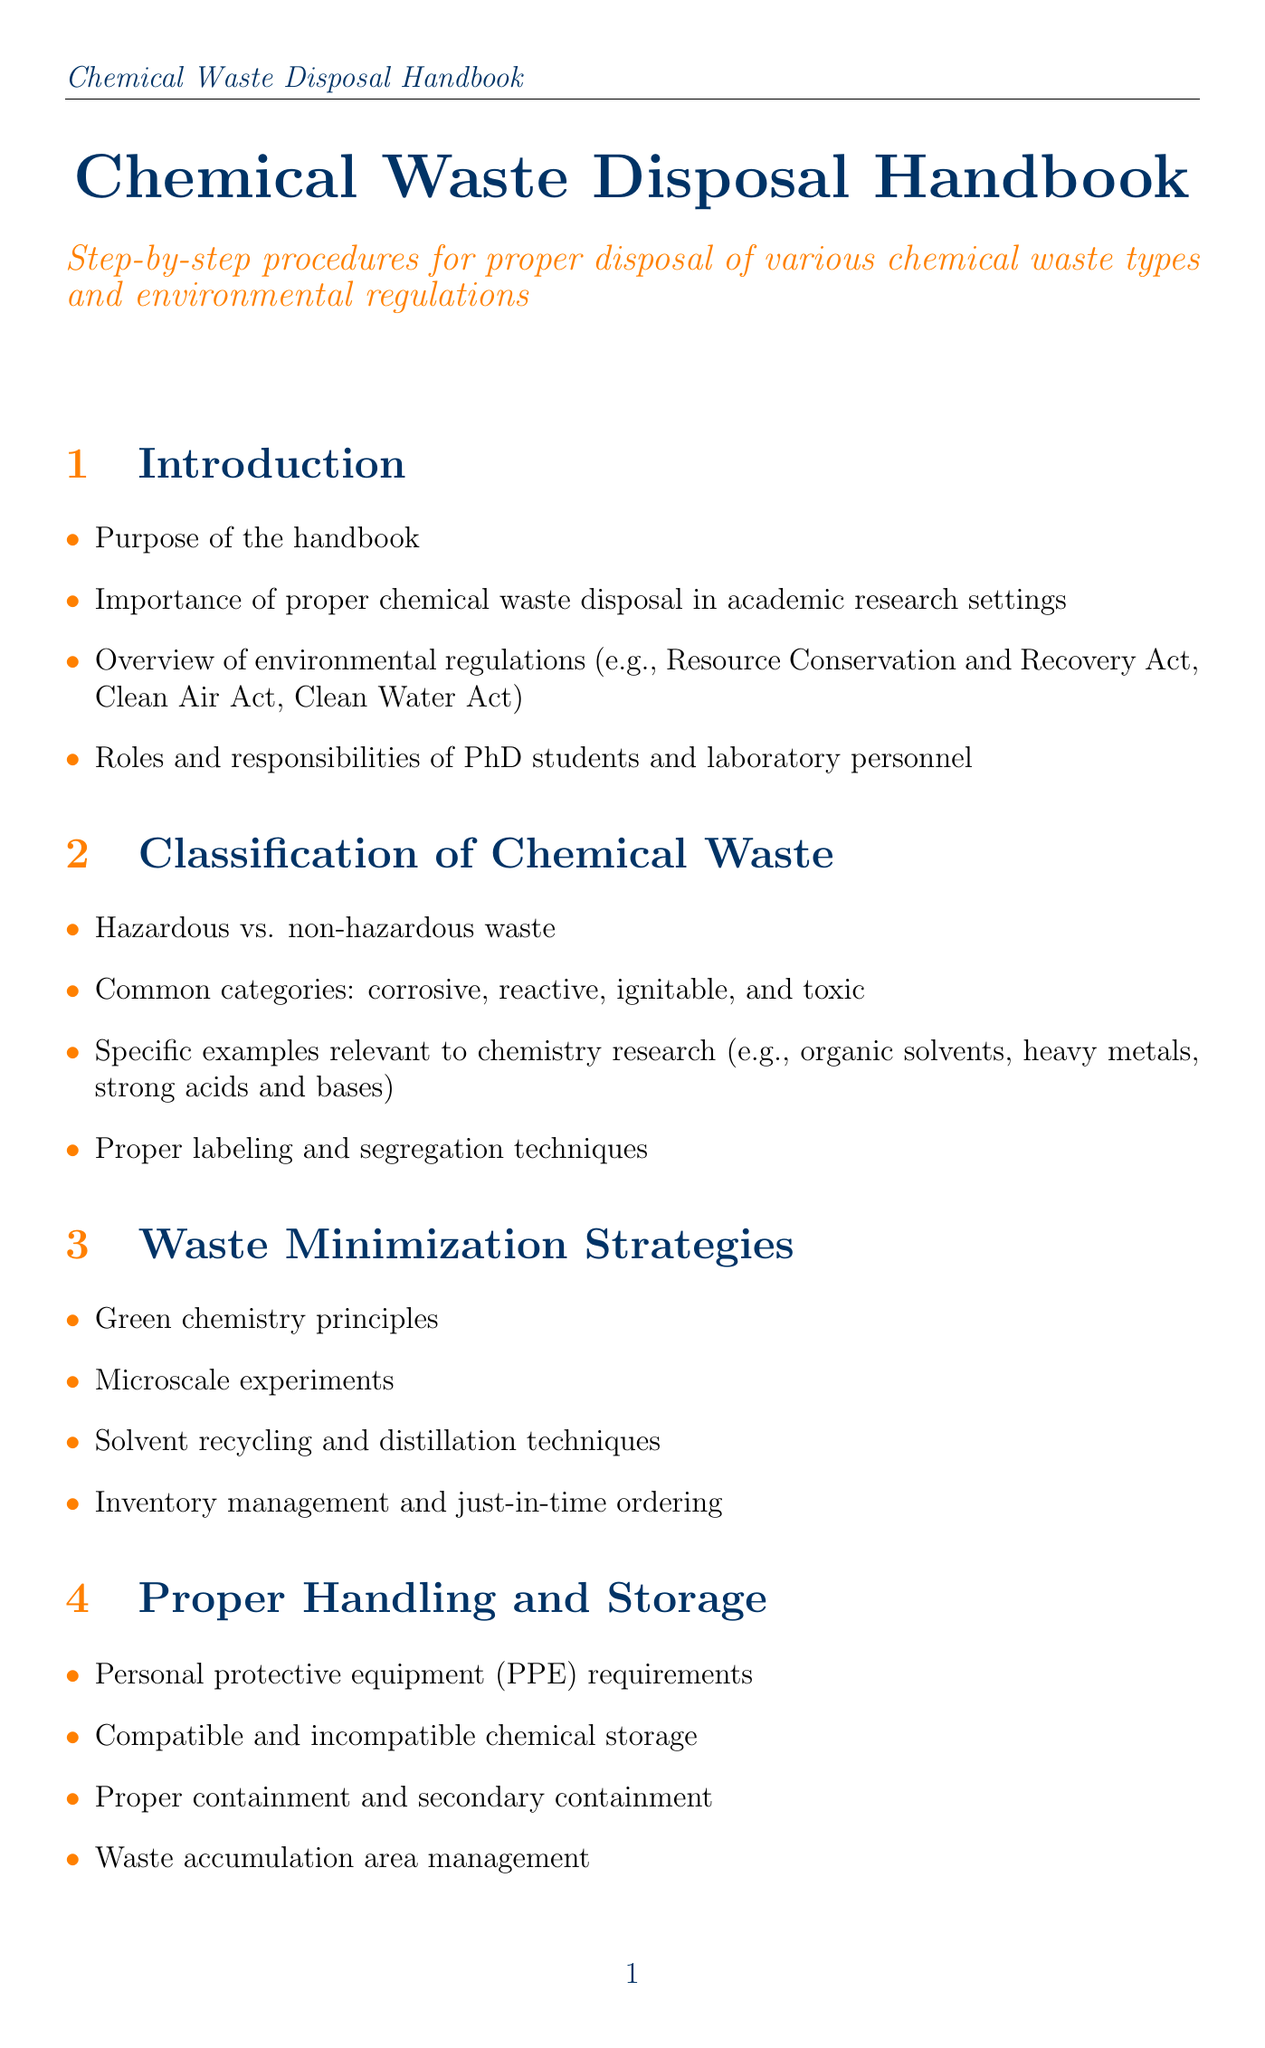What is the purpose of the handbook? The purpose of the handbook is outlined in the introduction section, which highlights its role in guiding proper chemical waste disposal.
Answer: Purpose of the handbook What are the common categories of chemical waste? This information is provided in the classification section, detailing the types of waste that need to be managed.
Answer: Corrosive, reactive, ignitable, and toxic What do waste manifests ensure? Waste manifests ensure proper documentation and tracking of hazardous waste as mentioned in the documentation section.
Answer: Proper documentation and tracking What is a strategy for chemical waste minimization mentioned in the manual? The waste minimization strategies section lists tactics for reducing chemical waste in laboratories.
Answer: Green chemistry principles What personal protective equipment requirement is highlighted? The manual indicates necessary personal protective equipment in the handling and storage section.
Answer: PPE requirements What is one disposal procedure for organic solvents? The disposal procedures section describes methods specific to different types of chemical waste.
Answer: Hexane, dichloromethane, acetone Which environmental regulation is mentioned? The overview in the introduction section lists key environmental regulations that govern waste disposal.
Answer: Resource Conservation and Recovery Act What type of incident requires reporting as per the manual? The emergency procedures section outlines incidents that should be reported for safety compliance purposes.
Answer: Near-misses What is provided in Appendix A? Appendix A outlines a tool to assist researchers in determining disposal methods for chemical waste.
Answer: Waste Disposal Decision Tree 